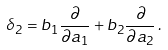<formula> <loc_0><loc_0><loc_500><loc_500>\delta _ { 2 } = b _ { 1 } \frac { \partial } { \partial a _ { 1 } } + b _ { 2 } \frac { \partial } { \partial a _ { 2 } } \, .</formula> 